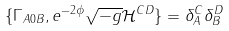<formula> <loc_0><loc_0><loc_500><loc_500>\{ \Gamma _ { A 0 B } , e ^ { - 2 \phi } \sqrt { - g } \mathcal { H } ^ { C D } \} = \delta ^ { C } _ { A } \delta _ { B } ^ { D }</formula> 